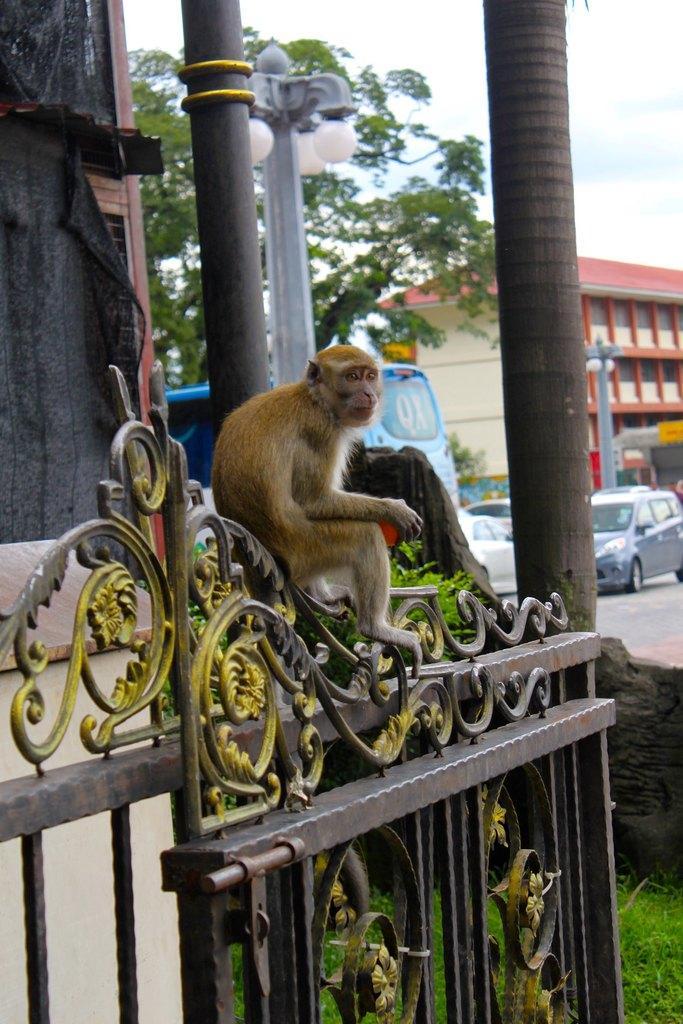Please provide a concise description of this image. Here is a monkey sitting on an iron gate. This looks like a pole. I think this is a tree trunk. These are the vehicles on the road. This looks like a building. I can see the street lights. Here is a tree. 